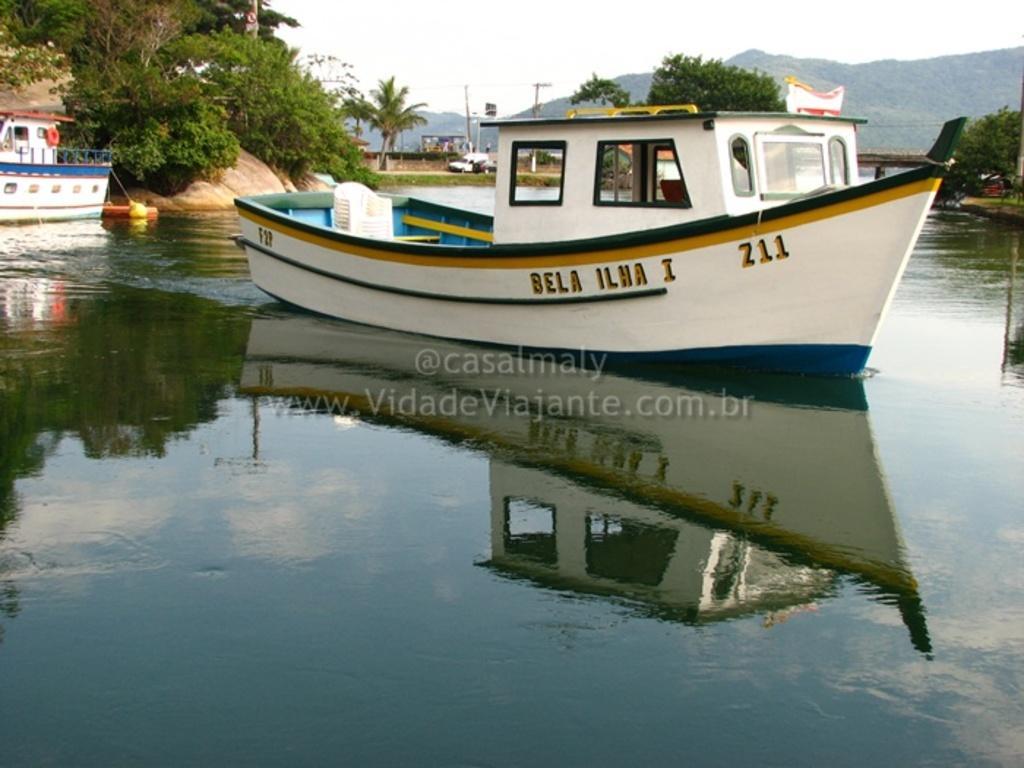Please provide a concise description of this image. In this image we can see white color boat on the surface of water. Behind tree, poles and mountains are there. Left side of the image one more boat is present. 